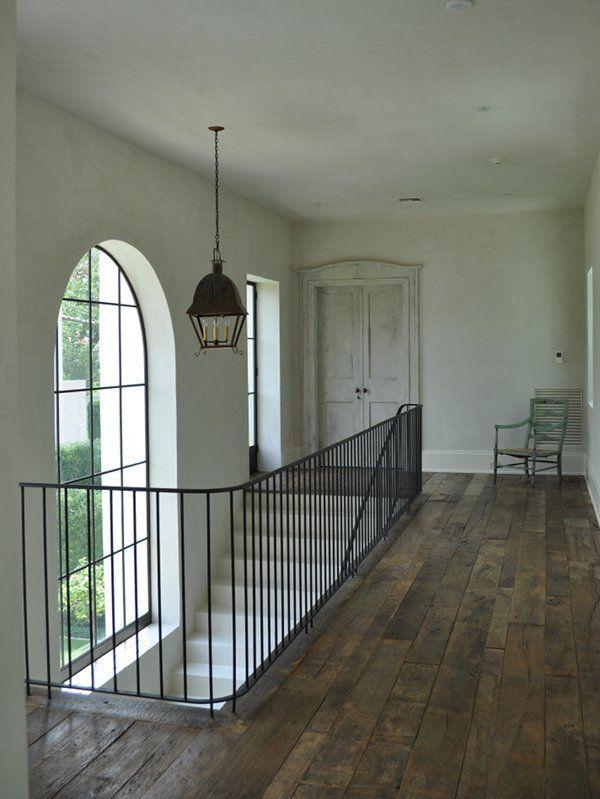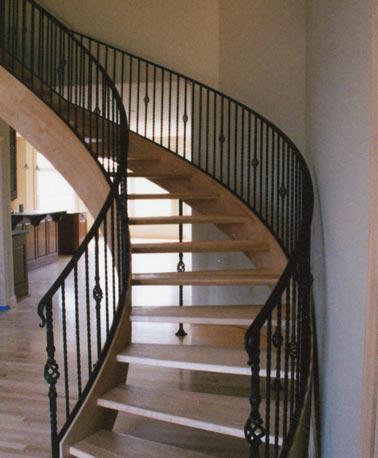The first image is the image on the left, the second image is the image on the right. Assess this claim about the two images: "In at least one image there is a brown wooden floor at the bottom of the staircase.". Correct or not? Answer yes or no. Yes. The first image is the image on the left, the second image is the image on the right. Given the left and right images, does the statement "The right image shows a staircase enclosed by white baseboard, with a dark handrail and white spindles, and the staircase ascends to a landing before turning directions." hold true? Answer yes or no. No. 